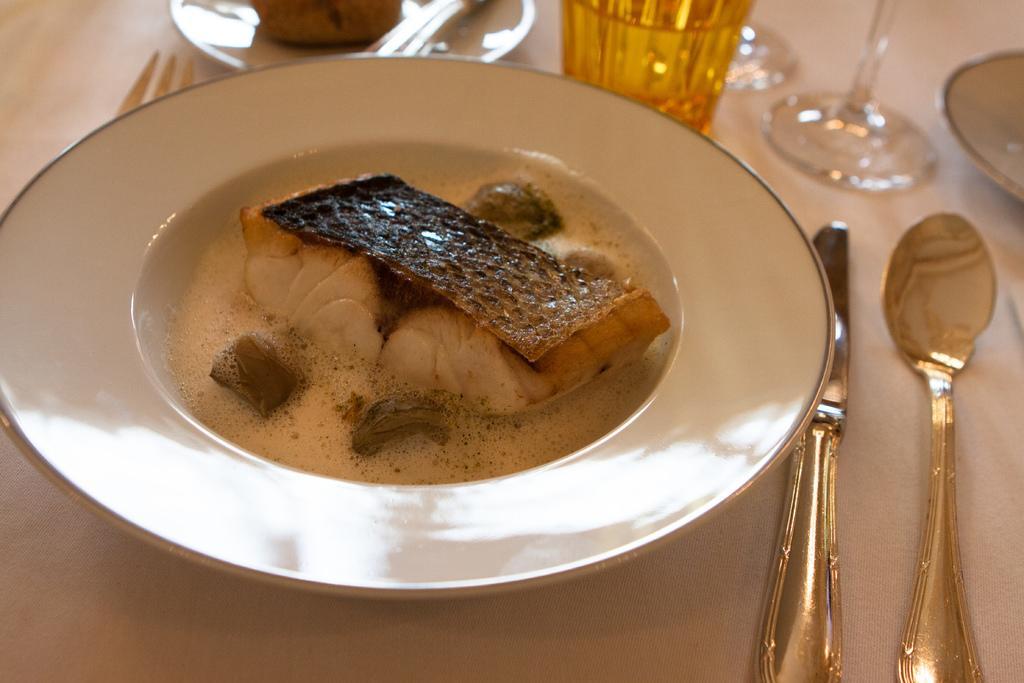Please provide a concise description of this image. In this picture I can see food item in the plate. I can knife and spoon on the right side. 